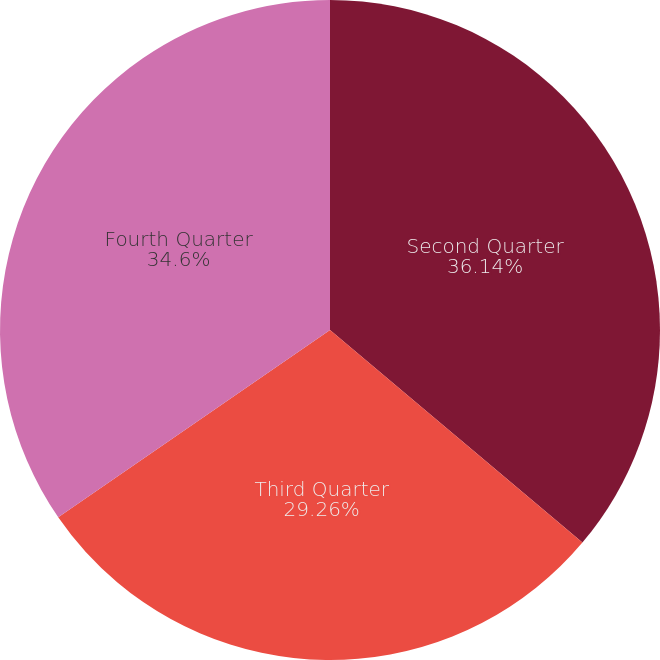<chart> <loc_0><loc_0><loc_500><loc_500><pie_chart><fcel>Second Quarter<fcel>Third Quarter<fcel>Fourth Quarter<nl><fcel>36.14%<fcel>29.26%<fcel>34.6%<nl></chart> 